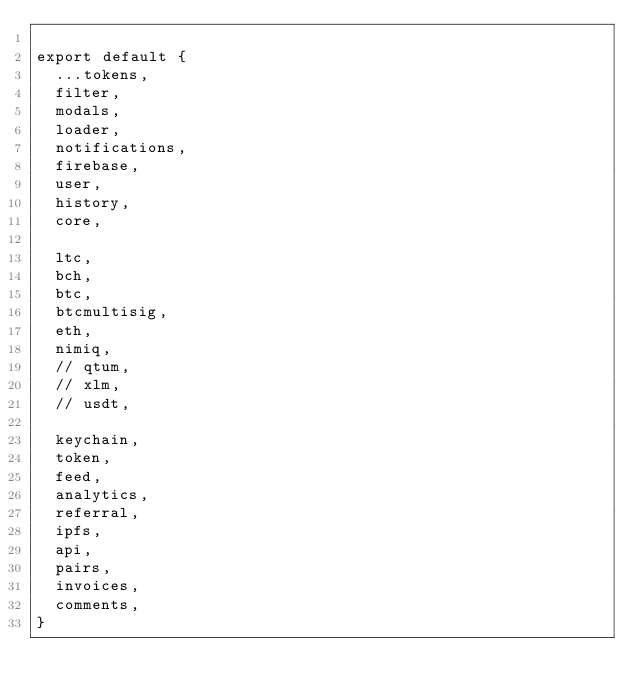<code> <loc_0><loc_0><loc_500><loc_500><_JavaScript_>
export default {
  ...tokens,
  filter,
  modals,
  loader,
  notifications,
  firebase,
  user,
  history,
  core,

  ltc,
  bch,
  btc,
  btcmultisig,
  eth,
  nimiq,
  // qtum,
  // xlm,
  // usdt,

  keychain,
  token,
  feed,
  analytics,
  referral,
  ipfs,
  api,
  pairs,
  invoices,
  comments,
}
</code> 